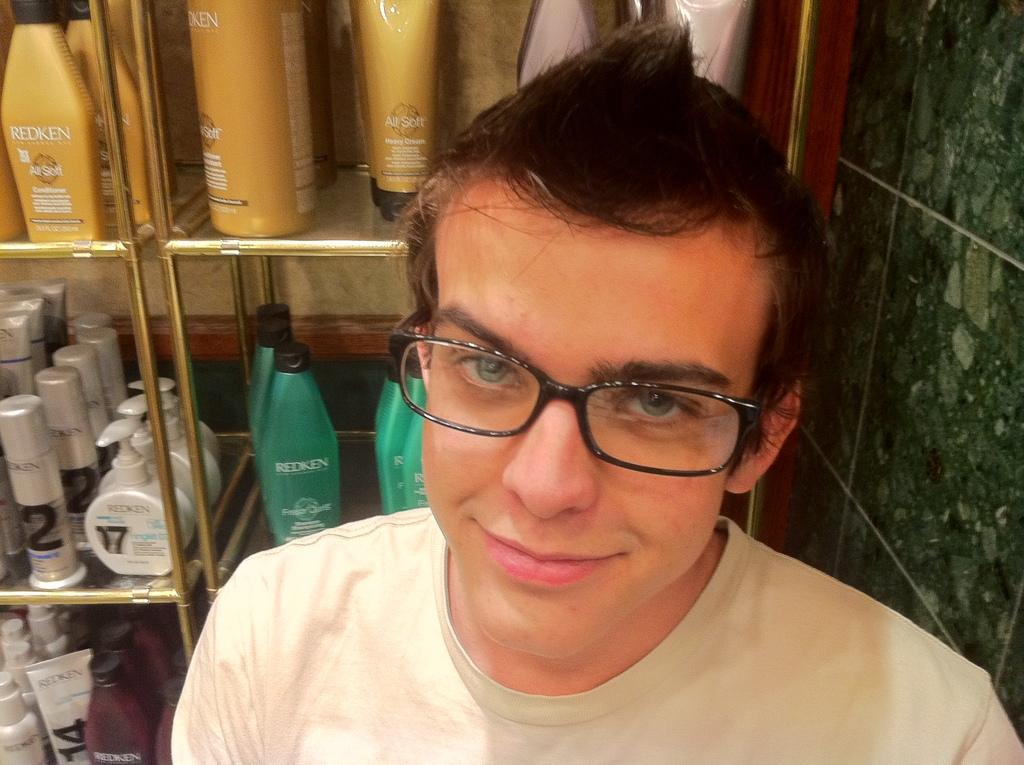<image>
Create a compact narrative representing the image presented. A young male with glasses on stands in front of a shelf with several Redken products on it. 